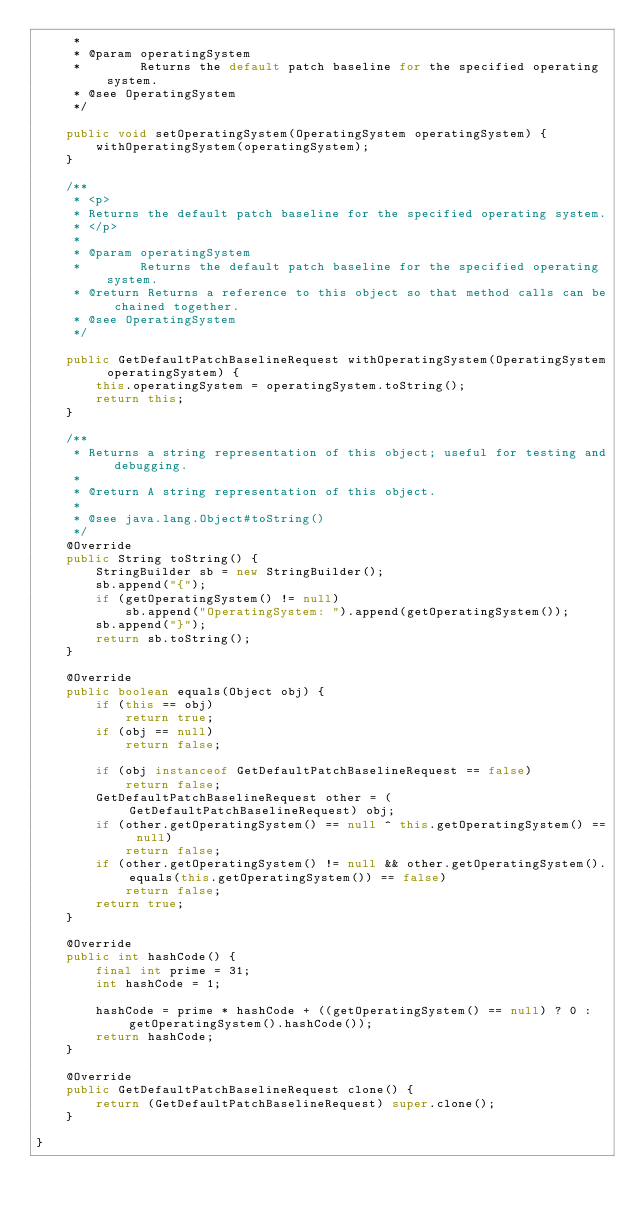<code> <loc_0><loc_0><loc_500><loc_500><_Java_>     * 
     * @param operatingSystem
     *        Returns the default patch baseline for the specified operating system.
     * @see OperatingSystem
     */

    public void setOperatingSystem(OperatingSystem operatingSystem) {
        withOperatingSystem(operatingSystem);
    }

    /**
     * <p>
     * Returns the default patch baseline for the specified operating system.
     * </p>
     * 
     * @param operatingSystem
     *        Returns the default patch baseline for the specified operating system.
     * @return Returns a reference to this object so that method calls can be chained together.
     * @see OperatingSystem
     */

    public GetDefaultPatchBaselineRequest withOperatingSystem(OperatingSystem operatingSystem) {
        this.operatingSystem = operatingSystem.toString();
        return this;
    }

    /**
     * Returns a string representation of this object; useful for testing and debugging.
     *
     * @return A string representation of this object.
     *
     * @see java.lang.Object#toString()
     */
    @Override
    public String toString() {
        StringBuilder sb = new StringBuilder();
        sb.append("{");
        if (getOperatingSystem() != null)
            sb.append("OperatingSystem: ").append(getOperatingSystem());
        sb.append("}");
        return sb.toString();
    }

    @Override
    public boolean equals(Object obj) {
        if (this == obj)
            return true;
        if (obj == null)
            return false;

        if (obj instanceof GetDefaultPatchBaselineRequest == false)
            return false;
        GetDefaultPatchBaselineRequest other = (GetDefaultPatchBaselineRequest) obj;
        if (other.getOperatingSystem() == null ^ this.getOperatingSystem() == null)
            return false;
        if (other.getOperatingSystem() != null && other.getOperatingSystem().equals(this.getOperatingSystem()) == false)
            return false;
        return true;
    }

    @Override
    public int hashCode() {
        final int prime = 31;
        int hashCode = 1;

        hashCode = prime * hashCode + ((getOperatingSystem() == null) ? 0 : getOperatingSystem().hashCode());
        return hashCode;
    }

    @Override
    public GetDefaultPatchBaselineRequest clone() {
        return (GetDefaultPatchBaselineRequest) super.clone();
    }

}
</code> 